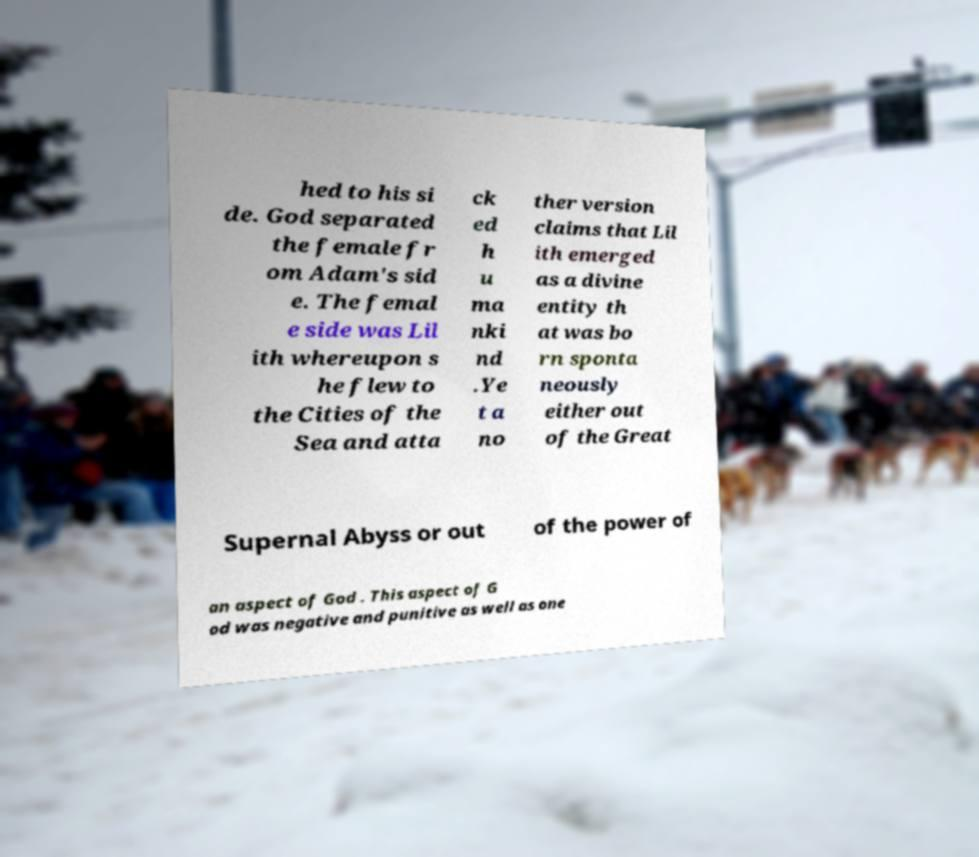I need the written content from this picture converted into text. Can you do that? hed to his si de. God separated the female fr om Adam's sid e. The femal e side was Lil ith whereupon s he flew to the Cities of the Sea and atta ck ed h u ma nki nd .Ye t a no ther version claims that Lil ith emerged as a divine entity th at was bo rn sponta neously either out of the Great Supernal Abyss or out of the power of an aspect of God . This aspect of G od was negative and punitive as well as one 